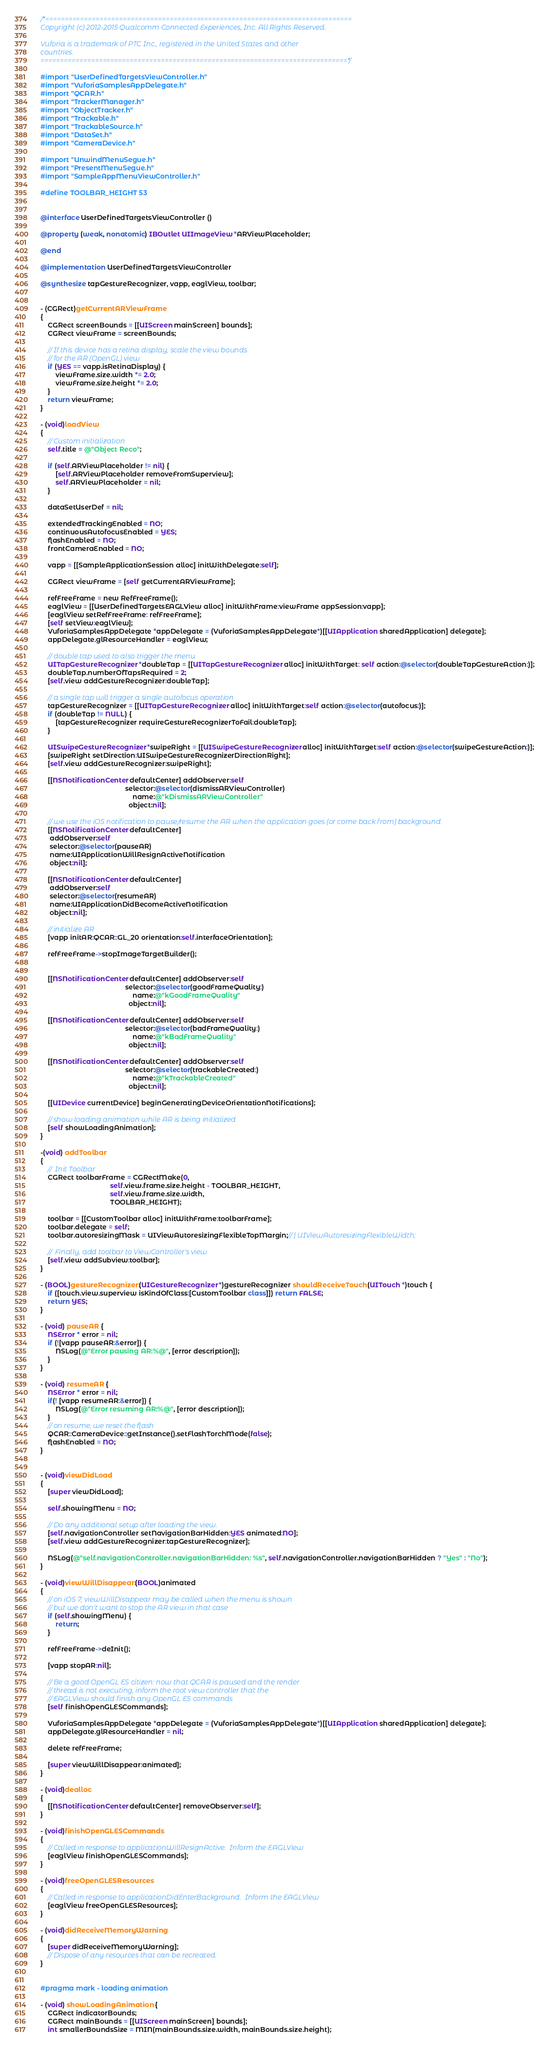Convert code to text. <code><loc_0><loc_0><loc_500><loc_500><_ObjectiveC_>/*===============================================================================
Copyright (c) 2012-2015 Qualcomm Connected Experiences, Inc. All Rights Reserved.

Vuforia is a trademark of PTC Inc., registered in the United States and other 
countries.
===============================================================================*/

#import "UserDefinedTargetsViewController.h"
#import "VuforiaSamplesAppDelegate.h"
#import "QCAR.h"
#import "TrackerManager.h"
#import "ObjectTracker.h"
#import "Trackable.h"
#import "TrackableSource.h"
#import "DataSet.h"
#import "CameraDevice.h"

#import "UnwindMenuSegue.h"
#import "PresentMenuSegue.h"
#import "SampleAppMenuViewController.h"

#define TOOLBAR_HEIGHT 53


@interface UserDefinedTargetsViewController ()

@property (weak, nonatomic) IBOutlet UIImageView *ARViewPlaceholder;

@end

@implementation UserDefinedTargetsViewController

@synthesize tapGestureRecognizer, vapp, eaglView, toolbar;


- (CGRect)getCurrentARViewFrame
{
    CGRect screenBounds = [[UIScreen mainScreen] bounds];
    CGRect viewFrame = screenBounds;
    
    // If this device has a retina display, scale the view bounds
    // for the AR (OpenGL) view
    if (YES == vapp.isRetinaDisplay) {
        viewFrame.size.width *= 2.0;
        viewFrame.size.height *= 2.0;
    }
    return viewFrame;
}

- (void)loadView
{
    // Custom initialization
    self.title = @"Object Reco";
    
    if (self.ARViewPlaceholder != nil) {
        [self.ARViewPlaceholder removeFromSuperview];
        self.ARViewPlaceholder = nil;
    }
    
    dataSetUserDef = nil;
    
    extendedTrackingEnabled = NO;
    continuousAutofocusEnabled = YES;
    flashEnabled = NO;
    frontCameraEnabled = NO;
    
    vapp = [[SampleApplicationSession alloc] initWithDelegate:self];
    
    CGRect viewFrame = [self getCurrentARViewFrame];
    
    refFreeFrame = new RefFreeFrame();
    eaglView = [[UserDefinedTargetsEAGLView alloc] initWithFrame:viewFrame appSession:vapp];
    [eaglView setRefFreeFrame: refFreeFrame];
    [self setView:eaglView];
    VuforiaSamplesAppDelegate *appDelegate = (VuforiaSamplesAppDelegate*)[[UIApplication sharedApplication] delegate];
    appDelegate.glResourceHandler = eaglView;
    
    // double tap used to also trigger the menu
    UITapGestureRecognizer *doubleTap = [[UITapGestureRecognizer alloc] initWithTarget: self action:@selector(doubleTapGestureAction:)];
    doubleTap.numberOfTapsRequired = 2;
    [self.view addGestureRecognizer:doubleTap];
    
    // a single tap will trigger a single autofocus operation
    tapGestureRecognizer = [[UITapGestureRecognizer alloc] initWithTarget:self action:@selector(autofocus:)];
    if (doubleTap != NULL) {
        [tapGestureRecognizer requireGestureRecognizerToFail:doubleTap];
    }
    
    UISwipeGestureRecognizer *swipeRight = [[UISwipeGestureRecognizer alloc] initWithTarget:self action:@selector(swipeGestureAction:)];
    [swipeRight setDirection:UISwipeGestureRecognizerDirectionRight];
    [self.view addGestureRecognizer:swipeRight];
    
    [[NSNotificationCenter defaultCenter] addObserver:self
                                             selector:@selector(dismissARViewController)
                                                 name:@"kDismissARViewController"
                                               object:nil];
    
    // we use the iOS notification to pause/resume the AR when the application goes (or come back from) background
    [[NSNotificationCenter defaultCenter]
     addObserver:self
     selector:@selector(pauseAR)
     name:UIApplicationWillResignActiveNotification
     object:nil];
    
    [[NSNotificationCenter defaultCenter]
     addObserver:self
     selector:@selector(resumeAR)
     name:UIApplicationDidBecomeActiveNotification
     object:nil];

    // initialize AR
    [vapp initAR:QCAR::GL_20 orientation:self.interfaceOrientation];

    refFreeFrame->stopImageTargetBuilder();
    
    
    [[NSNotificationCenter defaultCenter] addObserver:self
                                             selector:@selector(goodFrameQuality:)
                                                 name:@"kGoodFrameQuality"
                                               object:nil];
    
    [[NSNotificationCenter defaultCenter] addObserver:self
                                             selector:@selector(badFrameQuality:)
                                                 name:@"kBadFrameQuality"
                                               object:nil];
    
    [[NSNotificationCenter defaultCenter] addObserver:self
                                             selector:@selector(trackableCreated:)
                                                 name:@"kTrackableCreated"
                                               object:nil];
    
    [[UIDevice currentDevice] beginGeneratingDeviceOrientationNotifications];

    // show loading animation while AR is being initialized
    [self showLoadingAnimation];
}

-(void) addToolbar
{
    //  Init Toolbar
    CGRect toolbarFrame = CGRectMake(0,
                                     self.view.frame.size.height - TOOLBAR_HEIGHT,
                                     self.view.frame.size.width,
                                     TOOLBAR_HEIGHT);
    
    toolbar = [[CustomToolbar alloc] initWithFrame:toolbarFrame];
    toolbar.delegate = self;
    toolbar.autoresizingMask = UIViewAutoresizingFlexibleTopMargin;// | UIViewAutoresizingFlexibleWidth;
    
    //  Finally, add toolbar to ViewController's view
    [self.view addSubview:toolbar];
}

- (BOOL)gestureRecognizer:(UIGestureRecognizer *)gestureRecognizer shouldReceiveTouch:(UITouch *)touch {
    if ([touch.view.superview isKindOfClass:[CustomToolbar class]]) return FALSE;
    return YES;
}

- (void) pauseAR {
    NSError * error = nil;
    if (![vapp pauseAR:&error]) {
        NSLog(@"Error pausing AR:%@", [error description]);
    }
}

- (void) resumeAR {
    NSError * error = nil;
    if(! [vapp resumeAR:&error]) {
        NSLog(@"Error resuming AR:%@", [error description]);
    }
    // on resume, we reset the flash
    QCAR::CameraDevice::getInstance().setFlashTorchMode(false);
    flashEnabled = NO;
}


- (void)viewDidLoad
{
    [super viewDidLoad];
    
    self.showingMenu = NO;
    
    // Do any additional setup after loading the view.
    [self.navigationController setNavigationBarHidden:YES animated:NO];
    [self.view addGestureRecognizer:tapGestureRecognizer];
    
    NSLog(@"self.navigationController.navigationBarHidden: %s", self.navigationController.navigationBarHidden ? "Yes" : "No");
}

- (void)viewWillDisappear:(BOOL)animated
{
    // on iOS 7, viewWillDisappear may be called when the menu is shown
    // but we don't want to stop the AR view in that case
    if (self.showingMenu) {
        return;
    }
    
    refFreeFrame->deInit();

    [vapp stopAR:nil];
    
    // Be a good OpenGL ES citizen: now that QCAR is paused and the render
    // thread is not executing, inform the root view controller that the
    // EAGLView should finish any OpenGL ES commands
    [self finishOpenGLESCommands];
    
    VuforiaSamplesAppDelegate *appDelegate = (VuforiaSamplesAppDelegate*)[[UIApplication sharedApplication] delegate];
    appDelegate.glResourceHandler = nil;
    
    delete refFreeFrame;
    
    [super viewWillDisappear:animated];
}

- (void)dealloc
{
    [[NSNotificationCenter defaultCenter] removeObserver:self];
}

- (void)finishOpenGLESCommands
{
    // Called in response to applicationWillResignActive.  Inform the EAGLView
    [eaglView finishOpenGLESCommands];
}

- (void)freeOpenGLESResources
{
    // Called in response to applicationDidEnterBackground.  Inform the EAGLView
    [eaglView freeOpenGLESResources];
}

- (void)didReceiveMemoryWarning
{
    [super didReceiveMemoryWarning];
    // Dispose of any resources that can be recreated.
}


#pragma mark - loading animation

- (void) showLoadingAnimation {
    CGRect indicatorBounds;
    CGRect mainBounds = [[UIScreen mainScreen] bounds];
    int smallerBoundsSize = MIN(mainBounds.size.width, mainBounds.size.height);</code> 